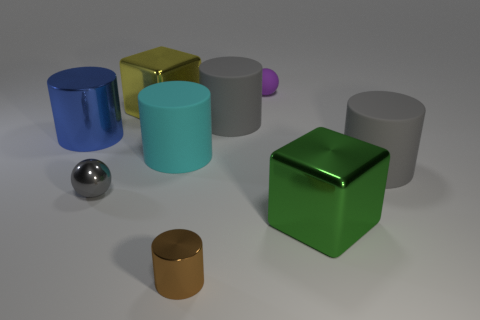The shiny cylinder that is the same size as the yellow thing is what color?
Ensure brevity in your answer.  Blue. What number of things are either large cylinders that are to the left of the gray metallic thing or small purple spheres?
Offer a very short reply. 2. What is the material of the big yellow thing that is on the left side of the gray rubber cylinder that is on the left side of the small purple matte sphere?
Offer a very short reply. Metal. Are there any gray spheres that have the same material as the big blue cylinder?
Keep it short and to the point. Yes. There is a gray metal object left of the small matte object; is there a purple rubber ball on the left side of it?
Provide a succinct answer. No. There is a gray thing that is behind the blue cylinder; what is it made of?
Ensure brevity in your answer.  Rubber. Is the large blue metallic thing the same shape as the large green object?
Provide a short and direct response. No. There is a metallic object to the right of the brown metal object that is to the left of the cylinder to the right of the large green object; what is its color?
Provide a short and direct response. Green. How many large cyan objects have the same shape as the yellow object?
Provide a short and direct response. 0. What is the size of the gray rubber object on the left side of the cylinder to the right of the green shiny thing?
Your answer should be compact. Large. 